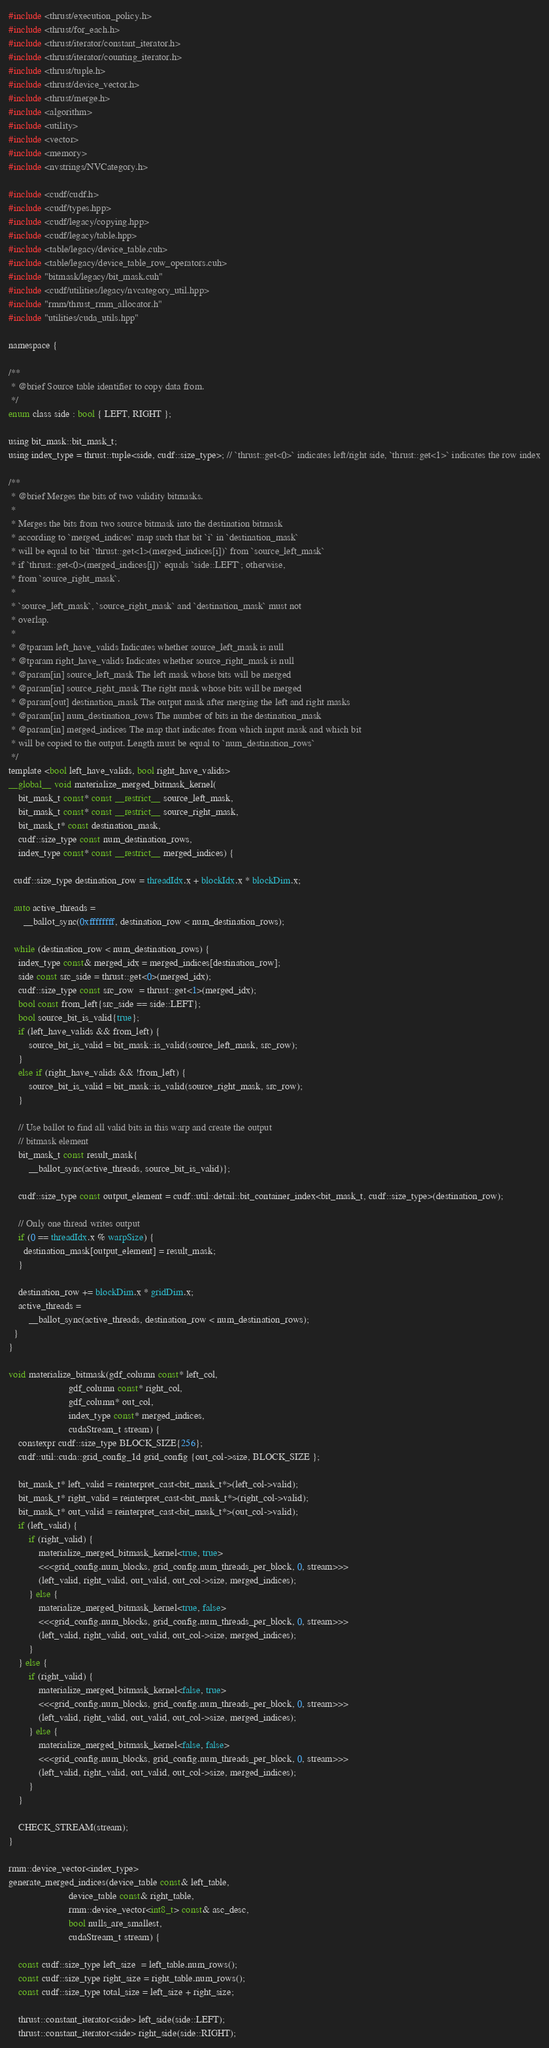<code> <loc_0><loc_0><loc_500><loc_500><_Cuda_>
#include <thrust/execution_policy.h>
#include <thrust/for_each.h>
#include <thrust/iterator/constant_iterator.h>
#include <thrust/iterator/counting_iterator.h>
#include <thrust/tuple.h>
#include <thrust/device_vector.h>
#include <thrust/merge.h>
#include <algorithm>
#include <utility>
#include <vector>
#include <memory>
#include <nvstrings/NVCategory.h>

#include <cudf/cudf.h>
#include <cudf/types.hpp>
#include <cudf/legacy/copying.hpp>
#include <cudf/legacy/table.hpp>
#include <table/legacy/device_table.cuh>
#include <table/legacy/device_table_row_operators.cuh>
#include "bitmask/legacy/bit_mask.cuh"
#include <cudf/utilities/legacy/nvcategory_util.hpp>
#include "rmm/thrust_rmm_allocator.h"
#include "utilities/cuda_utils.hpp"

namespace {

/**
 * @brief Source table identifier to copy data from.
 */
enum class side : bool { LEFT, RIGHT };

using bit_mask::bit_mask_t;
using index_type = thrust::tuple<side, cudf::size_type>; // `thrust::get<0>` indicates left/right side, `thrust::get<1>` indicates the row index

/**
 * @brief Merges the bits of two validity bitmasks.
 *
 * Merges the bits from two source bitmask into the destination bitmask
 * according to `merged_indices` map such that bit `i` in `destination_mask`
 * will be equal to bit `thrust::get<1>(merged_indices[i])` from `source_left_mask`
 * if `thrust::get<0>(merged_indices[i])` equals `side::LEFT`; otherwise,
 * from `source_right_mask`.
 *
 * `source_left_mask`, `source_right_mask` and `destination_mask` must not
 * overlap.
 *
 * @tparam left_have_valids Indicates whether source_left_mask is null
 * @tparam right_have_valids Indicates whether source_right_mask is null
 * @param[in] source_left_mask The left mask whose bits will be merged
 * @param[in] source_right_mask The right mask whose bits will be merged
 * @param[out] destination_mask The output mask after merging the left and right masks
 * @param[in] num_destination_rows The number of bits in the destination_mask
 * @param[in] merged_indices The map that indicates from which input mask and which bit
 * will be copied to the output. Length must be equal to `num_destination_rows`
 */
template <bool left_have_valids, bool right_have_valids>
__global__ void materialize_merged_bitmask_kernel(
    bit_mask_t const* const __restrict__ source_left_mask,
    bit_mask_t const* const __restrict__ source_right_mask,
    bit_mask_t* const destination_mask,
    cudf::size_type const num_destination_rows,
    index_type const* const __restrict__ merged_indices) {

  cudf::size_type destination_row = threadIdx.x + blockIdx.x * blockDim.x;

  auto active_threads =
      __ballot_sync(0xffffffff, destination_row < num_destination_rows);

  while (destination_row < num_destination_rows) {
    index_type const& merged_idx = merged_indices[destination_row];
    side const src_side = thrust::get<0>(merged_idx);
    cudf::size_type const src_row  = thrust::get<1>(merged_idx);
    bool const from_left{src_side == side::LEFT};
    bool source_bit_is_valid{true};
    if (left_have_valids && from_left) {
        source_bit_is_valid = bit_mask::is_valid(source_left_mask, src_row);
    }
    else if (right_have_valids && !from_left) {
        source_bit_is_valid = bit_mask::is_valid(source_right_mask, src_row);
    }
    
    // Use ballot to find all valid bits in this warp and create the output
    // bitmask element
    bit_mask_t const result_mask{
        __ballot_sync(active_threads, source_bit_is_valid)};

    cudf::size_type const output_element = cudf::util::detail::bit_container_index<bit_mask_t, cudf::size_type>(destination_row);
    
    // Only one thread writes output
    if (0 == threadIdx.x % warpSize) {
      destination_mask[output_element] = result_mask;
    }

    destination_row += blockDim.x * gridDim.x;
    active_threads =
        __ballot_sync(active_threads, destination_row < num_destination_rows);
  }
}

void materialize_bitmask(gdf_column const* left_col,
                        gdf_column const* right_col,
                        gdf_column* out_col,
                        index_type const* merged_indices,
                        cudaStream_t stream) {
    constexpr cudf::size_type BLOCK_SIZE{256};
    cudf::util::cuda::grid_config_1d grid_config {out_col->size, BLOCK_SIZE };

    bit_mask_t* left_valid = reinterpret_cast<bit_mask_t*>(left_col->valid);
    bit_mask_t* right_valid = reinterpret_cast<bit_mask_t*>(right_col->valid);
    bit_mask_t* out_valid = reinterpret_cast<bit_mask_t*>(out_col->valid);
    if (left_valid) {
        if (right_valid) {
            materialize_merged_bitmask_kernel<true, true>
            <<<grid_config.num_blocks, grid_config.num_threads_per_block, 0, stream>>>
            (left_valid, right_valid, out_valid, out_col->size, merged_indices);
        } else {
            materialize_merged_bitmask_kernel<true, false>
            <<<grid_config.num_blocks, grid_config.num_threads_per_block, 0, stream>>>
            (left_valid, right_valid, out_valid, out_col->size, merged_indices);
        }
    } else {
        if (right_valid) {
            materialize_merged_bitmask_kernel<false, true>
            <<<grid_config.num_blocks, grid_config.num_threads_per_block, 0, stream>>>
            (left_valid, right_valid, out_valid, out_col->size, merged_indices);
        } else {
            materialize_merged_bitmask_kernel<false, false>
            <<<grid_config.num_blocks, grid_config.num_threads_per_block, 0, stream>>>
            (left_valid, right_valid, out_valid, out_col->size, merged_indices);
        }
    }

    CHECK_STREAM(stream);
}

rmm::device_vector<index_type>
generate_merged_indices(device_table const& left_table,
                        device_table const& right_table,
                        rmm::device_vector<int8_t> const& asc_desc,
                        bool nulls_are_smallest,
                        cudaStream_t stream) {

    const cudf::size_type left_size  = left_table.num_rows();
    const cudf::size_type right_size = right_table.num_rows();
    const cudf::size_type total_size = left_size + right_size;

    thrust::constant_iterator<side> left_side(side::LEFT);
    thrust::constant_iterator<side> right_side(side::RIGHT);
</code> 